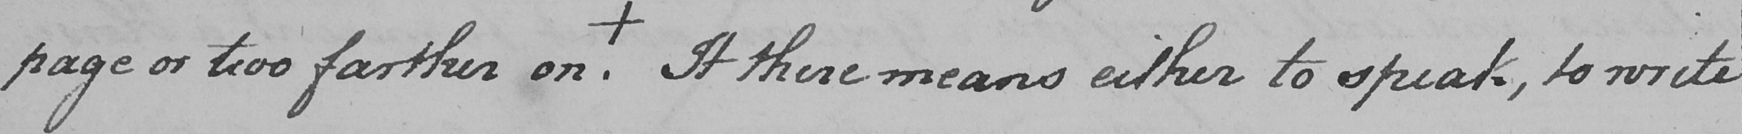Please provide the text content of this handwritten line. page or two farther on . +  It there means either to speak,to write 